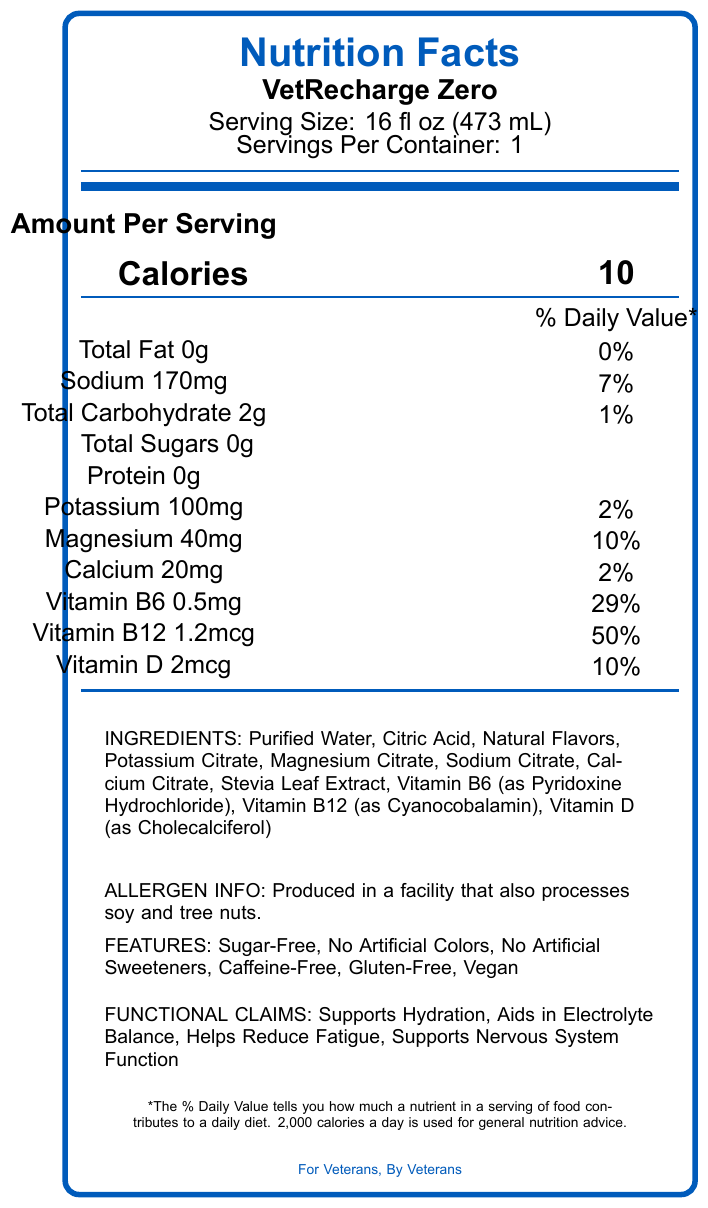what is the serving size for VetRecharge Zero? The serving size is listed as 16 fl oz (473 mL) in the document.
Answer: 16 fl oz (473 mL) How many calories are in a serving of VetRecharge Zero? The document states that one serving of VetRecharge Zero contains 10 calories.
Answer: 10 What is the amount of sodium per serving? The Nutrition Facts label indicates that there are 170mg of sodium per serving, which is 7% of the daily value.
Answer: 170mg How much Vitamin B12 is in a serving and what percentage of the daily value does it provide? The label shows that a serving contains 1.2mcg of Vitamin B12, which is 50% of the daily value.
Answer: 1.2mcg, 50% What is the percentage of the daily value for Magnesium in VetRecharge Zero? The document shows that the serving of VetRecharge Zero provides 40mg of magnesium, which is 10% of the daily value.
Answer: 10% Which of the following ingredients is not in VetRecharge Zero?
A. Calcium Citrate
B. Stevia Leaf Extract
C. Aspartame
D. Potassium Citrate Aspartame is not listed as one of the ingredients, whereas Calcium Citrate, Stevia Leaf Extract, and Potassium Citrate are.
Answer: C. Aspartame What special features does VetRecharge Zero have? The document lists these special features under the features section.
Answer: Sugar-Free, No Artificial Colors, No Artificial Sweeteners, Caffeine-Free, Gluten-Free, Vegan Is VetRecharge Zero Gluten-Free? The document states that VetRecharge Zero is Gluten-Free under the special features section.
Answer: Yes How much potassium does one serving of VetRecharge Zero contain? The Nutrition Facts label indicates that there are 100mg of potassium per serving, which is 2% of the daily value.
Answer: 100mg Which vitamins are included in VetRecharge Zero (select all that apply)?
I. Vitamin C
II. Vitamin D
III. Vitamin B6
IV. Vitamin B12 The label lists Vitamin D, Vitamin B6, and Vitamin B12 as ingredients, while Vitamin C is not included.
Answer: II, III, IV What is the recommended usage for VetRecharge Zero? The usage instructions section advises consuming 1-2 bottles daily and mentions that the product is best served chilled.
Answer: Consume 1-2 bottles daily or as recommended by your healthcare provider. Best served chilled. What claims does VetRecharge Zero make regarding its functional benefits? These functional benefits are listed under the functional claims section in the document.
Answer: Supports Hydration, Aids in Electrolyte Balance, Helps Reduce Fatigue, Supports Nervous System Function Who is the manufacturer of VetRecharge Zero? The document states that VetCare Nutrition, Inc. is the manufacturer.
Answer: VetCare Nutrition, Inc. Summarize the main nutritional information for VetRecharge Zero. The main nutritional information summarizes the key nutrients and their quantities per serving as stated in the document.
Answer: VetRecharge Zero contains 10 calories per 16 fl oz (473 mL) serving, with 0g of fat, 170mg of sodium, 2g of carbohydrates, 0g of sugars, 0g of protein, 100mg of potassium, 40mg of magnesium, 20mg of calcium, 0.5mg of Vitamin B6, 1.2mcg of Vitamin B12, and 2mcg of Vitamin D. What are the storage instructions for VetRecharge Zero? The storage instructions specify to keep the product in a cool, dry place, refrigerate after opening, and consume within 3 days.
Answer: Store in a cool, dry place. Refrigerate after opening and consume within 3 days. What should you do if you have questions or feedback about the product? The document provides this contact information for questions or feedback.
Answer: Contact 1-800-VET-CARE or support@vetcarenutrition.com How is VetRecharge Zero related to veterans? The document does not provide specific information on how VetRecharge Zero is related to veterans beyond the involvement of the manufacturer and distributor.
Answer: I don't know 